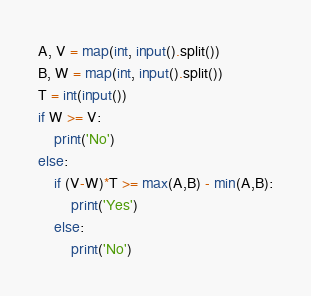Convert code to text. <code><loc_0><loc_0><loc_500><loc_500><_Python_>A, V = map(int, input().split())
B, W = map(int, input().split())
T = int(input())
if W >= V:
    print('No')
else:
    if (V-W)*T >= max(A,B) - min(A,B):
        print('Yes')
    else:
        print('No')</code> 